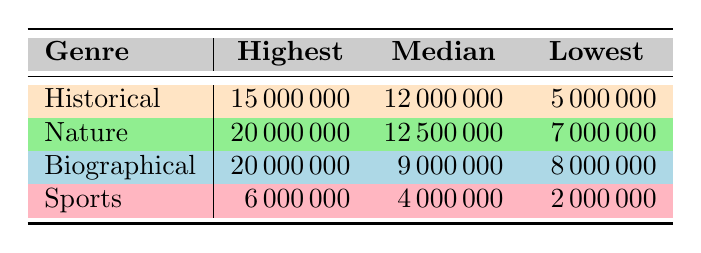What is the highest box office revenue for historical documentaries? From the table, the historical documentary with the highest box office revenue is "The Last Days of World War II" with a revenue of 15000000.
Answer: 15000000 What is the median box office revenue for nature documentaries? According to the table, the median box office revenue for nature documentaries is 12500000.
Answer: 12500000 Is the lowest box office revenue for historical documentaries greater than 4000000? The lowest box office revenue for historical documentaries is 5000000, which is greater than 4000000.
Answer: Yes What is the difference between the highest box office revenue of historical documentaries and that of biographical documentaries? The highest box office revenue for historical documentaries is 15000000, and for biographical documentaries, it is also 20000000. The difference is 20000000 - 15000000 = 5000000.
Answer: 5000000 What is the average box office revenue for the sports documentary genre? The sports documentary revenues are 4000000, 2000000, and 6000000. To find the average, we sum these values: 4000000 + 2000000 + 6000000 = 12000000. Then, we divide by the number of films: 12000000 / 3 = 4000000.
Answer: 4000000 Which documentary genre has the highest median box office revenue? By comparing the median values from the table, nature has a median of 12500000, biographical has 9000000, historical has 12000000, and sports has 4000000. Hence, nature documentaries have the highest median revenue.
Answer: Nature Are there any documentary genres with the same highest box office revenue? Yes, both nature and biographical genres have the highest box office revenue of 20000000.
Answer: Yes How much more is the lowest box office revenue for nature documentaries compared to historical documentaries? The lowest for nature is 7000000 and for historical is 5000000. The difference is calculated as 7000000 - 5000000 = 2000000.
Answer: 2000000 